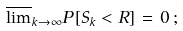Convert formula to latex. <formula><loc_0><loc_0><loc_500><loc_500>\overline { \lim } _ { k \rightarrow \infty } P \left [ S _ { k } < R \right ] \, = \, 0 \, ;</formula> 